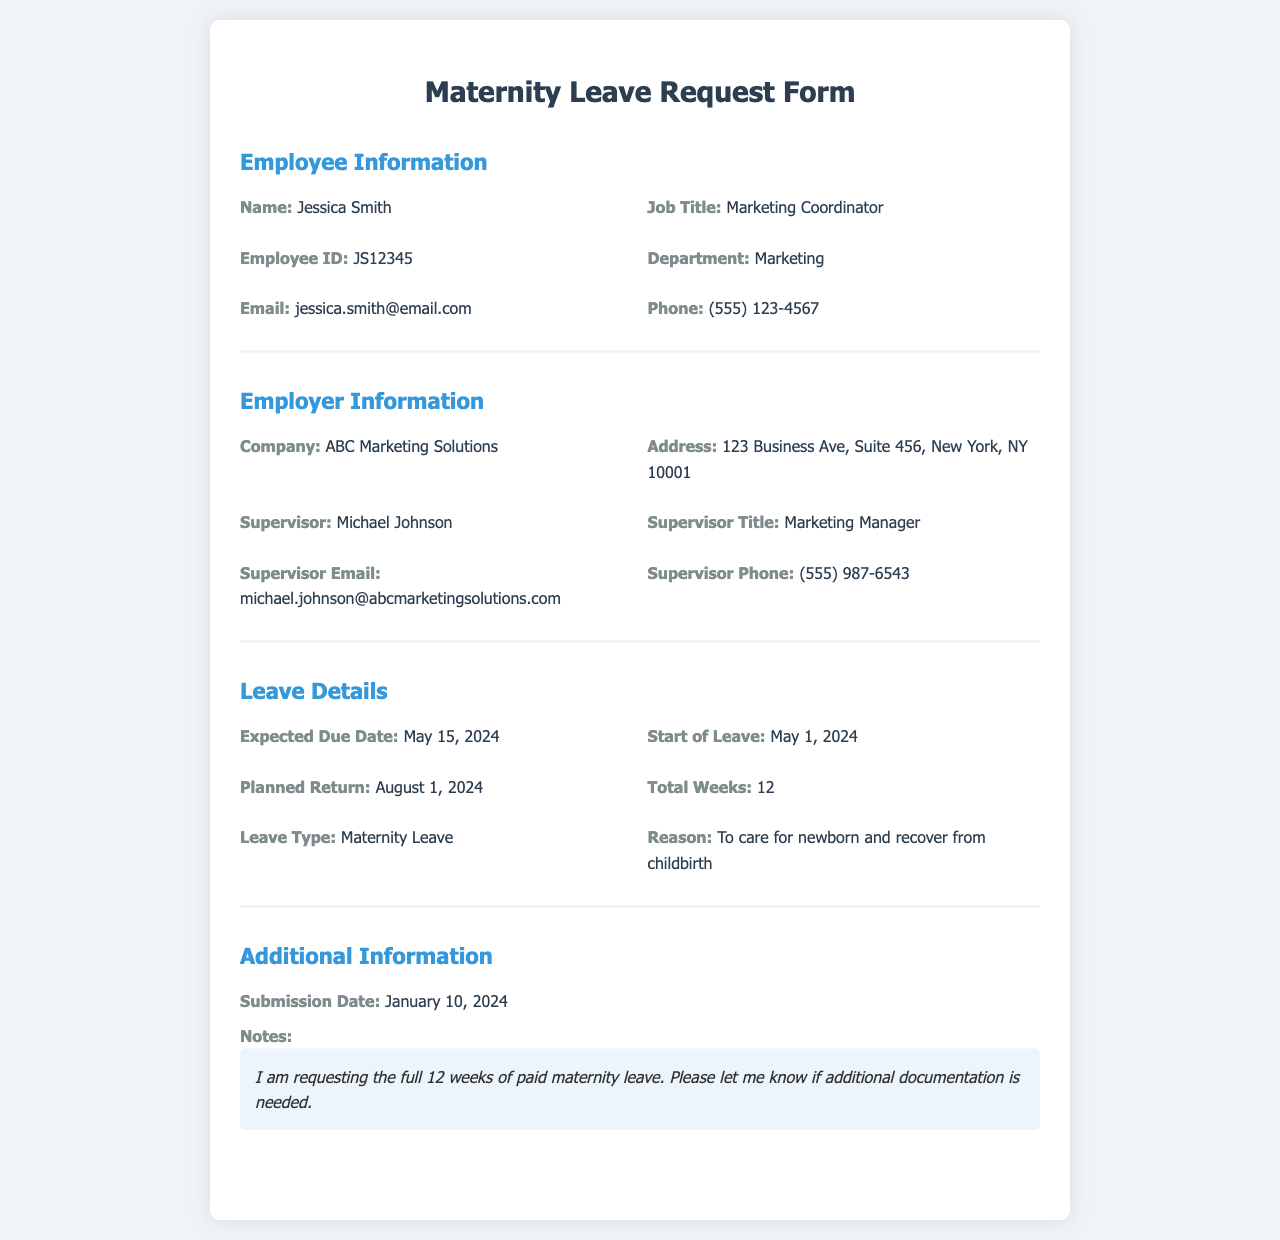What is the employee's name? The document states the employee's name in the Employee Information section, which is Jessica Smith.
Answer: Jessica Smith What is the expected due date? The expected due date is found in the Leave Details section of the document, which is May 15, 2024.
Answer: May 15, 2024 Who is the supervisor? The supervisor's name is listed in the Employer Information section and is Michael Johnson.
Answer: Michael Johnson What is the start date of the leave? The start date of the leave can be found in the Leave Details section, which is May 1, 2024.
Answer: May 1, 2024 How many total weeks of leave is requested? The total weeks of leave are mentioned in the Leave Details section, which is 12.
Answer: 12 What is the reason for the leave? The reason for the leave is provided in the Leave Details section, which states it is to care for newborn and recover from childbirth.
Answer: To care for newborn and recover from childbirth What is the submission date of the request? The submission date can be found in the Additional Information section, which is January 10, 2024.
Answer: January 10, 2024 What is the planned return date? The planned return date is specified in the Leave Details section as August 1, 2024.
Answer: August 1, 2024 What type of leave is being requested? The type of leave is found in the Leave Details section, which states Maternity Leave.
Answer: Maternity Leave 